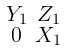Convert formula to latex. <formula><loc_0><loc_0><loc_500><loc_500>\begin{smallmatrix} Y _ { 1 } & Z _ { 1 } \\ 0 & X _ { 1 } \end{smallmatrix}</formula> 